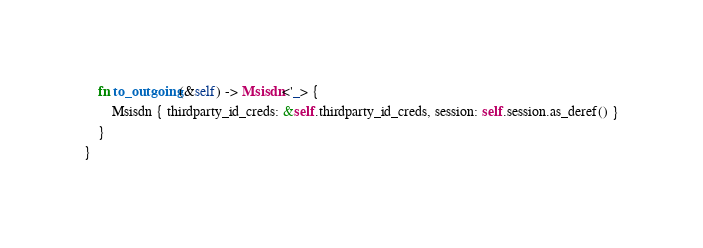<code> <loc_0><loc_0><loc_500><loc_500><_Rust_>    fn to_outgoing(&self) -> Msisdn<'_> {
        Msisdn { thirdparty_id_creds: &self.thirdparty_id_creds, session: self.session.as_deref() }
    }
}
</code> 